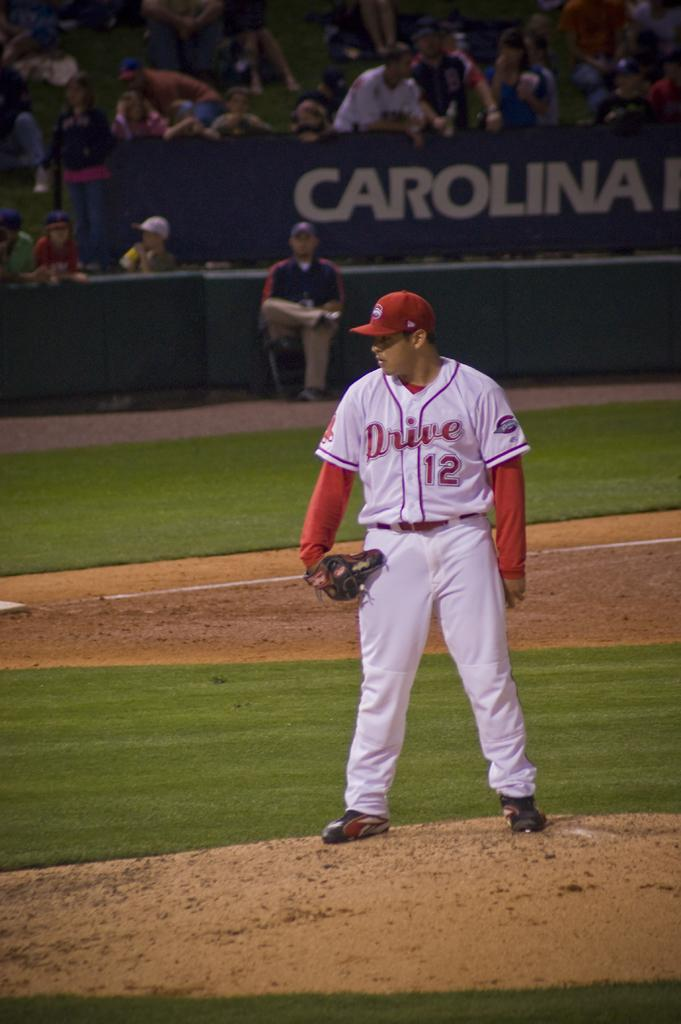<image>
Offer a succinct explanation of the picture presented. A man wearing a Drive jersey number 12 stands on the pitcher's mound. 